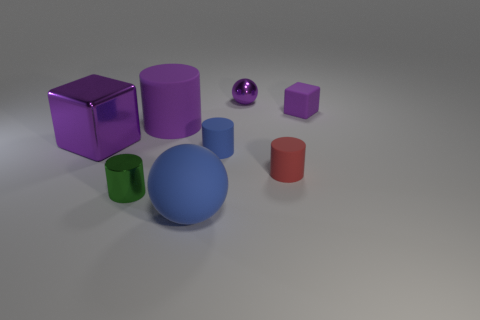Is the material of the big thing behind the purple metal cube the same as the small purple sphere?
Your answer should be compact. No. How many tiny yellow things are the same shape as the red thing?
Offer a very short reply. 0. What number of small things are blue blocks or metal things?
Your answer should be very brief. 2. There is a tiny shiny thing to the left of the big sphere; does it have the same color as the large sphere?
Provide a succinct answer. No. Do the metal object behind the purple matte cube and the large rubber object in front of the green shiny thing have the same color?
Your response must be concise. No. Are there any green cylinders that have the same material as the small purple block?
Ensure brevity in your answer.  No. How many green things are small metallic cylinders or spheres?
Provide a succinct answer. 1. Are there more small green shiny things that are to the left of the big blue rubber object than green cubes?
Ensure brevity in your answer.  Yes. Do the green shiny thing and the purple rubber block have the same size?
Provide a succinct answer. Yes. There is a large sphere that is made of the same material as the tiny red thing; what is its color?
Your answer should be compact. Blue. 